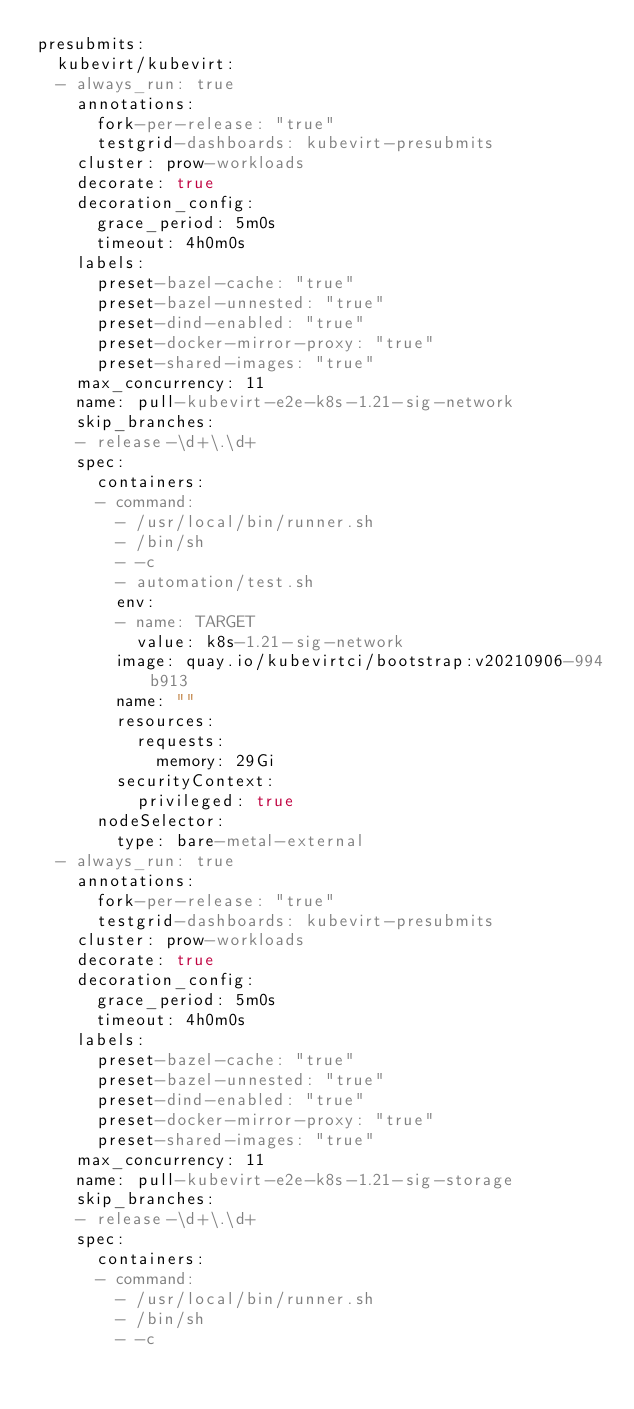<code> <loc_0><loc_0><loc_500><loc_500><_YAML_>presubmits:
  kubevirt/kubevirt:
  - always_run: true
    annotations:
      fork-per-release: "true"
      testgrid-dashboards: kubevirt-presubmits
    cluster: prow-workloads
    decorate: true
    decoration_config:
      grace_period: 5m0s
      timeout: 4h0m0s
    labels:
      preset-bazel-cache: "true"
      preset-bazel-unnested: "true"
      preset-dind-enabled: "true"
      preset-docker-mirror-proxy: "true"
      preset-shared-images: "true"
    max_concurrency: 11
    name: pull-kubevirt-e2e-k8s-1.21-sig-network
    skip_branches:
    - release-\d+\.\d+
    spec:
      containers:
      - command:
        - /usr/local/bin/runner.sh
        - /bin/sh
        - -c
        - automation/test.sh
        env:
        - name: TARGET
          value: k8s-1.21-sig-network
        image: quay.io/kubevirtci/bootstrap:v20210906-994b913
        name: ""
        resources:
          requests:
            memory: 29Gi
        securityContext:
          privileged: true
      nodeSelector:
        type: bare-metal-external
  - always_run: true
    annotations:
      fork-per-release: "true"
      testgrid-dashboards: kubevirt-presubmits
    cluster: prow-workloads
    decorate: true
    decoration_config:
      grace_period: 5m0s
      timeout: 4h0m0s
    labels:
      preset-bazel-cache: "true"
      preset-bazel-unnested: "true"
      preset-dind-enabled: "true"
      preset-docker-mirror-proxy: "true"
      preset-shared-images: "true"
    max_concurrency: 11
    name: pull-kubevirt-e2e-k8s-1.21-sig-storage
    skip_branches:
    - release-\d+\.\d+
    spec:
      containers:
      - command:
        - /usr/local/bin/runner.sh
        - /bin/sh
        - -c</code> 